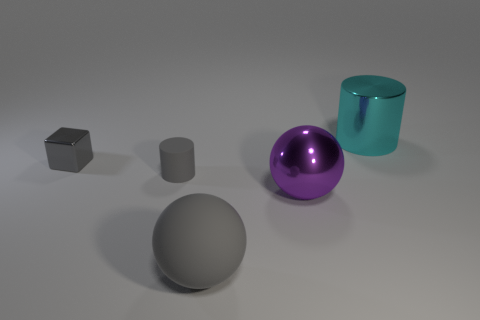What time of day or lighting conditions does this scene represent? The scene doesn't clearly represent a time of day, but the soft shadows and even lighting suggest an artificial, diffused light source, resembling a studio light setup. This controlled environment allows for consistent illumination on all objects, with no direct sunlight or harsh shadows that you'd expect from natural outdoor lighting. 